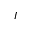Convert formula to latex. <formula><loc_0><loc_0><loc_500><loc_500>I</formula> 